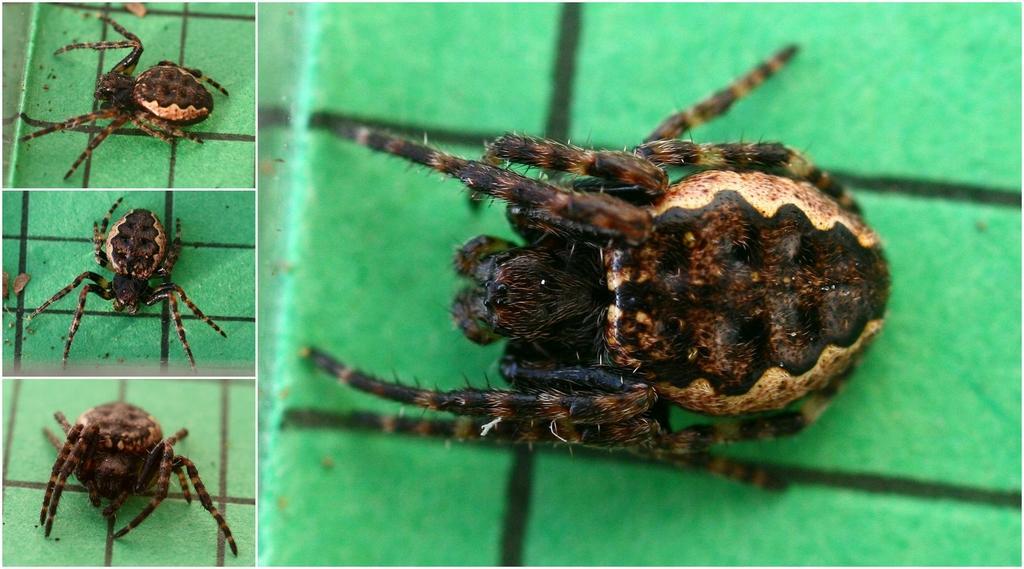In one or two sentences, can you explain what this image depicts? In this image we can see collages of a spider. 